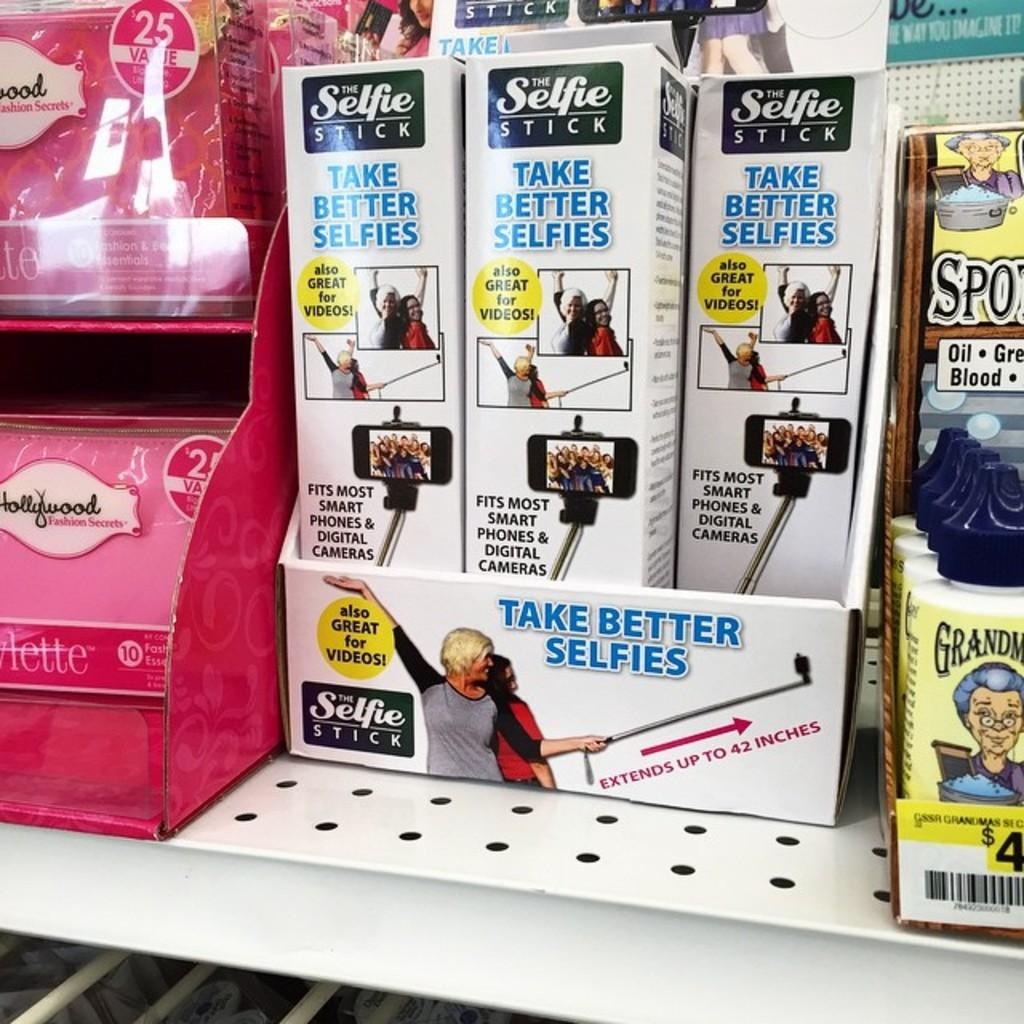What objects are present in the image that are typically used for storage or containment? There are boxes and bottles in the image. What can be seen on the boxes in the image? Text is written on the boxes. Where are the boxes and bottles located in the image? The boxes and bottles are on a shelf. Can you tell me how many times the person in the image looks at the poisonous snake? There is no person or poisonous snake present in the image; it only features boxes and bottles on a shelf. 